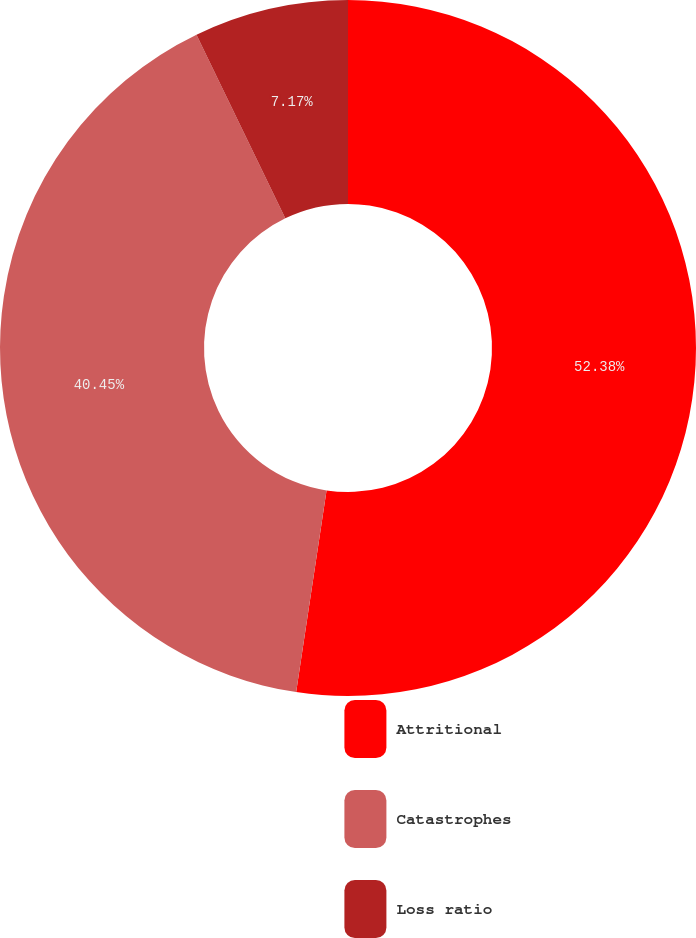Convert chart. <chart><loc_0><loc_0><loc_500><loc_500><pie_chart><fcel>Attritional<fcel>Catastrophes<fcel>Loss ratio<nl><fcel>52.38%<fcel>40.45%<fcel>7.17%<nl></chart> 